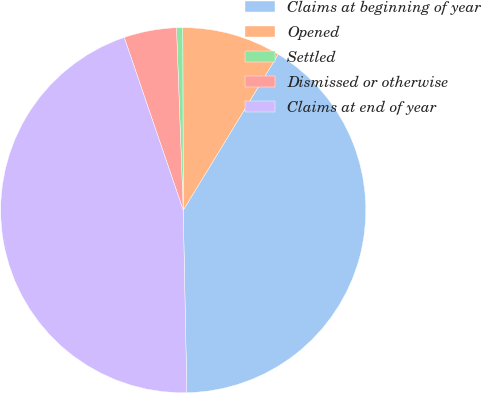Convert chart to OTSL. <chart><loc_0><loc_0><loc_500><loc_500><pie_chart><fcel>Claims at beginning of year<fcel>Opened<fcel>Settled<fcel>Dismissed or otherwise<fcel>Claims at end of year<nl><fcel>40.98%<fcel>8.75%<fcel>0.55%<fcel>4.65%<fcel>45.08%<nl></chart> 